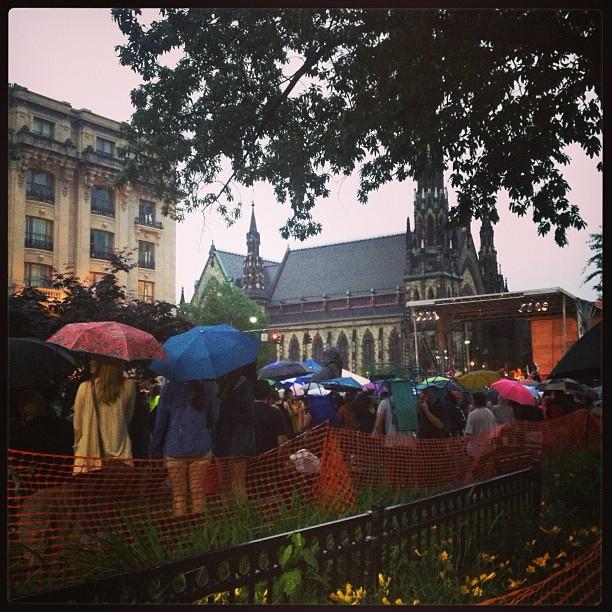Are these people at a concert?
Be succinct. Yes. Are these new buildings?
Answer briefly. No. What color are the flowers?
Answer briefly. Yellow. Why do the people have umbrellas?
Answer briefly. Rain. Is it raining?
Concise answer only. Yes. Do most of the people have umbrellas?
Answer briefly. Yes. 